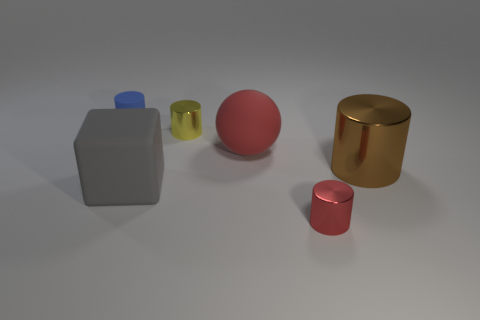Subtract 1 cylinders. How many cylinders are left? 3 Add 3 large cubes. How many objects exist? 9 Subtract all spheres. How many objects are left? 5 Subtract 0 blue balls. How many objects are left? 6 Subtract all big red metallic cubes. Subtract all brown metal cylinders. How many objects are left? 5 Add 3 red objects. How many red objects are left? 5 Add 2 yellow metallic balls. How many yellow metallic balls exist? 2 